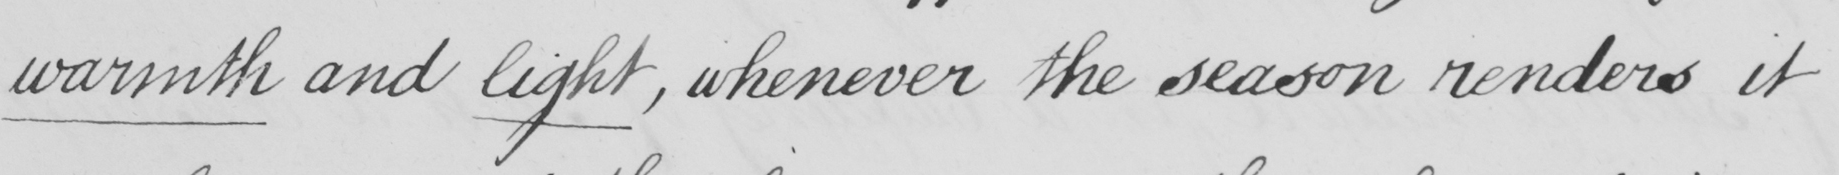What is written in this line of handwriting? warmth and light, whenever the season renders it 